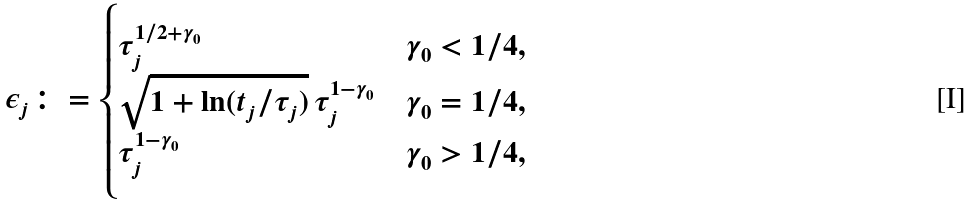Convert formula to latex. <formula><loc_0><loc_0><loc_500><loc_500>\epsilon _ { j } \colon = \begin{cases} \tau _ { j } ^ { 1 / 2 + \gamma _ { 0 } } & \gamma _ { 0 } < 1 / 4 , \\ \sqrt { 1 + \ln ( t _ { j } / \tau _ { j } ) } \, \tau _ { j } ^ { 1 - \gamma _ { 0 } } & \gamma _ { 0 } = 1 / 4 , \\ \tau _ { j } ^ { 1 - \gamma _ { 0 } } & \gamma _ { 0 } > 1 / 4 , \end{cases}</formula> 